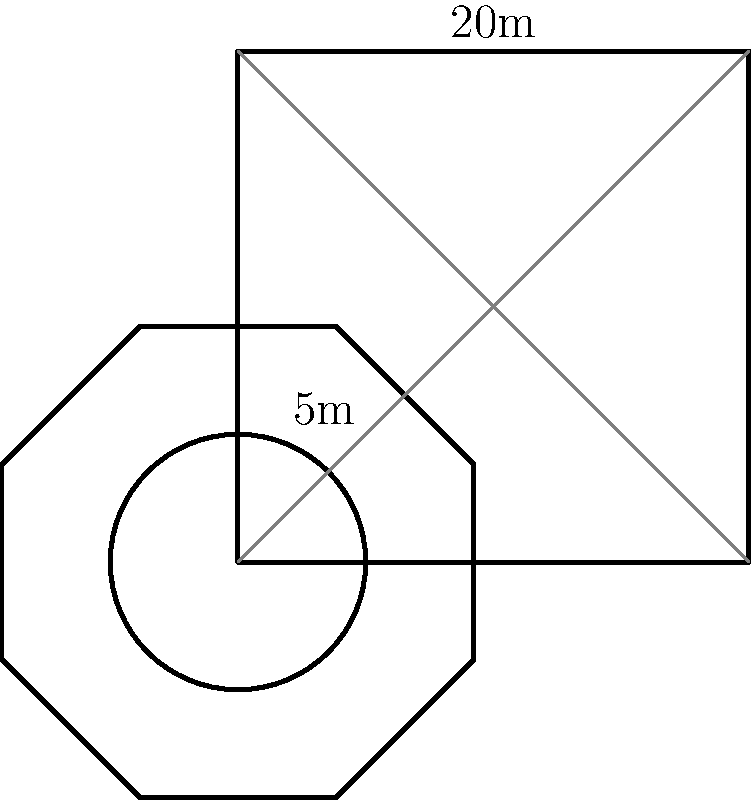As a former lieutenant, you're tasked with calculating the total area of a new helipad design. The design consists of a square base with side length 20m, an octagon in the center, and a circular landing zone in the middle. The octagon's side length is 5m, and the circle's diameter is 5m. What is the total area of the helipad in square meters? Round your answer to the nearest whole number. Let's break this down step-by-step:

1. Area of the square base:
   $A_{square} = 20m \times 20m = 400m^2$

2. Area of the octagon:
   For a regular octagon with side length $s$, the area is given by:
   $A_{octagon} = 2s^2(1+\sqrt{2})$
   With $s = 5m$:
   $A_{octagon} = 2(5m)^2(1+\sqrt{2}) \approx 121.22m^2$

3. Area of the circle:
   $A_{circle} = \pi r^2 = \pi (2.5m)^2 \approx 19.63m^2$

4. Total area:
   $A_{total} = A_{square} + A_{octagon} + A_{circle}$
   $A_{total} = 400m^2 + 121.22m^2 + 19.63m^2 = 540.85m^2$

5. Rounding to the nearest whole number:
   $541m^2$
Answer: $541m^2$ 